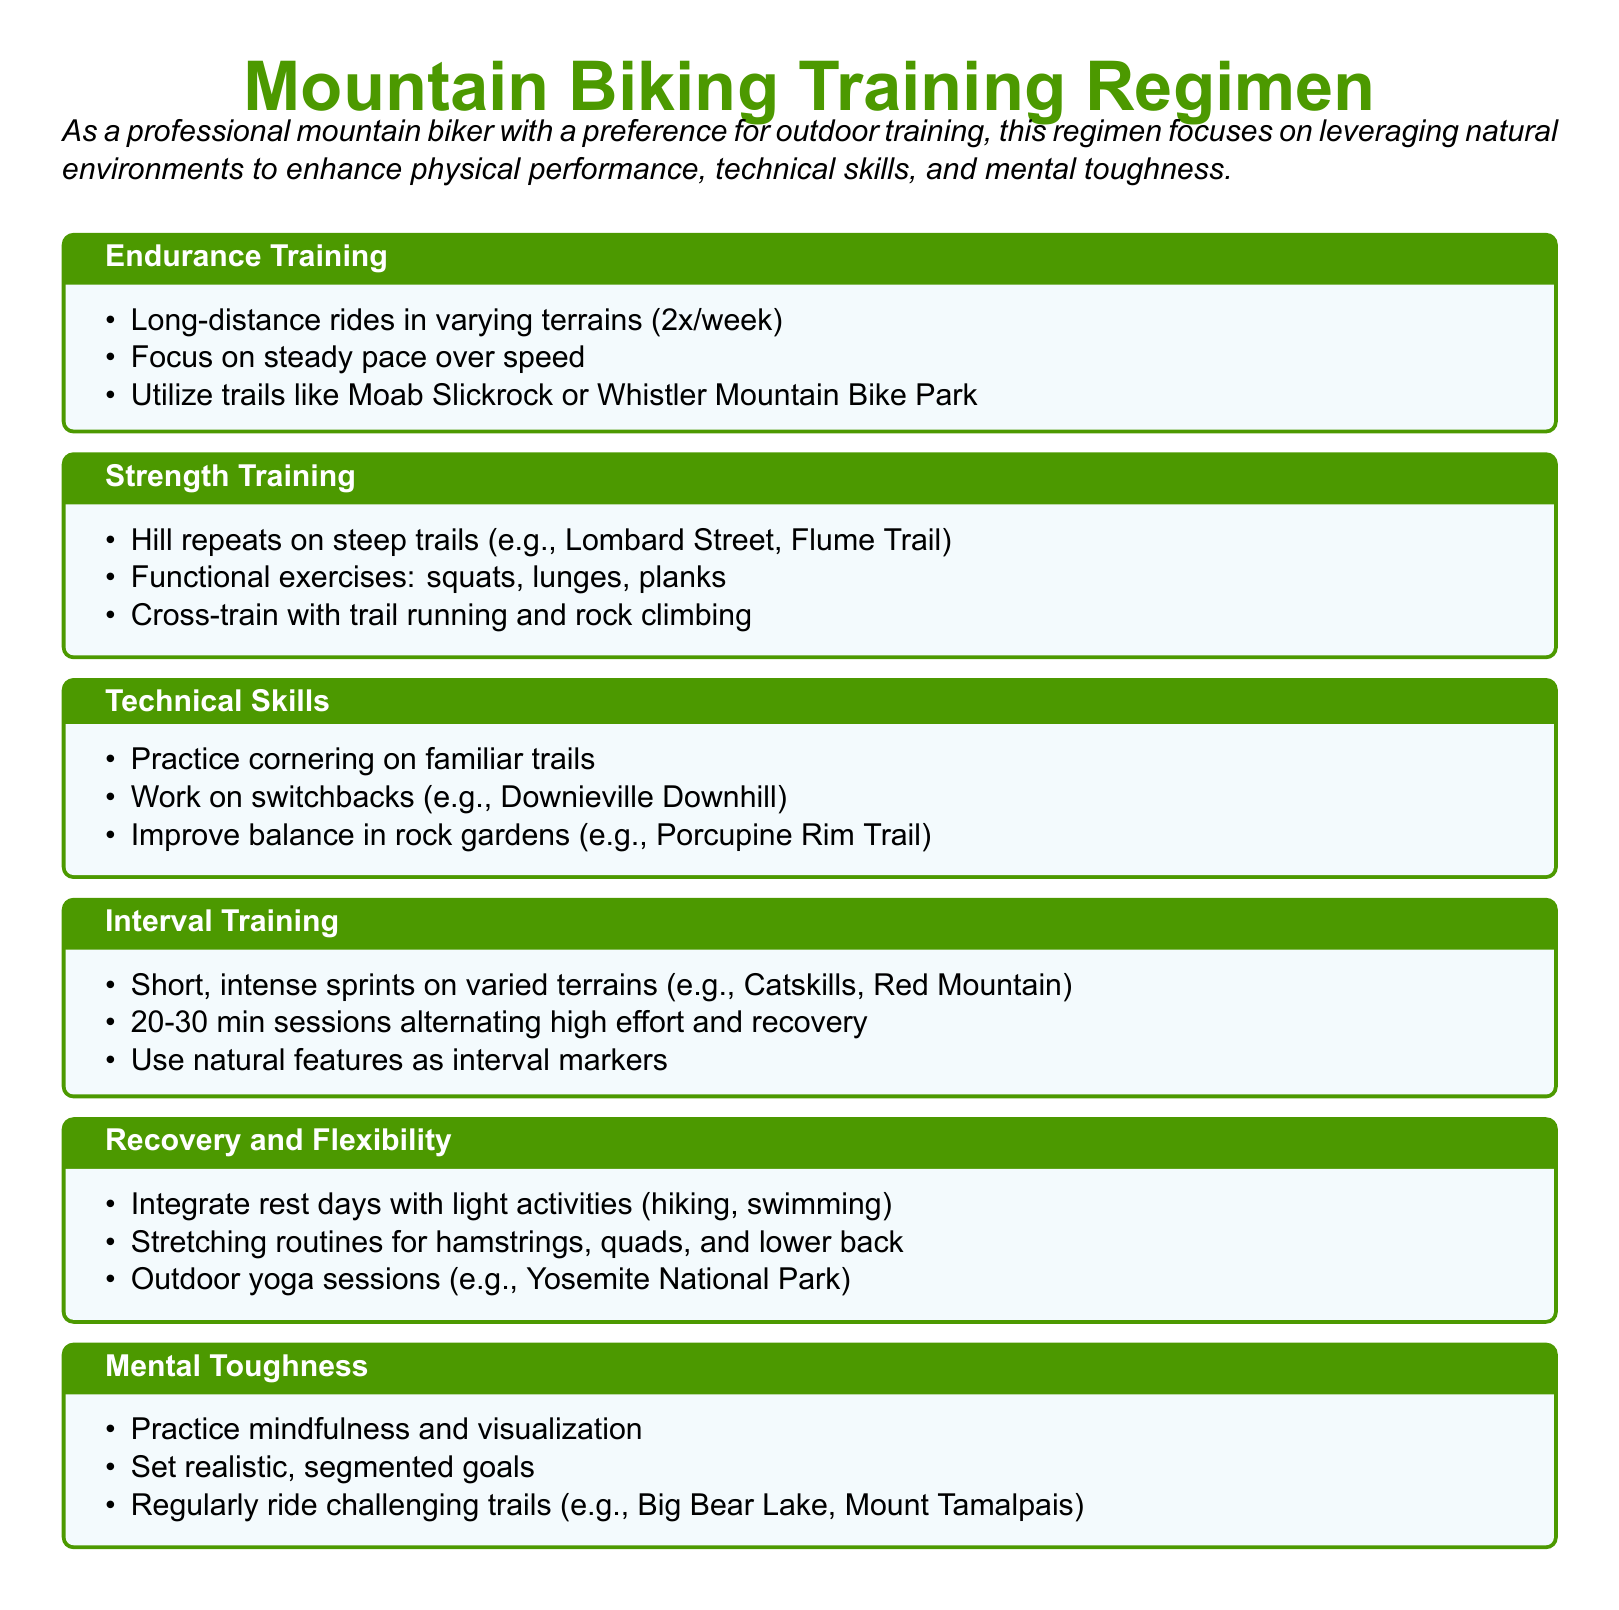What is the focus of the training regimen? The document states that the regimen focuses on leveraging natural environments to enhance physical performance, technical skills, and mental toughness.
Answer: leveraging natural environments How many days a week should endurance training occur? The document specifies that long-distance rides should take place twice a week.
Answer: 2x/week Name one location recommended for strength training hill repeats. The document mentions Lombard Street as a location for hill repeats in strength training.
Answer: Lombard Street What type of exercises are included in the strength training section? The document lists functional exercises such as squats, lunges, and planks under strength training.
Answer: squats, lunges, planks Which outdoor activity is suggested for recovery? The document mentions hiking as one of the light activities to integrate on rest days.
Answer: hiking What specific technique is recommended for improving balance? The document states that improving balance in rock gardens is a recommended technique.
Answer: rock gardens What is the duration of the interval training sessions? The document indicates that interval training sessions should last between 20 to 30 minutes.
Answer: 20-30 min Which park is suggested for outdoor yoga sessions? The document recommends Yosemite National Park for outdoor yoga sessions.
Answer: Yosemite National Park What skill is emphasized in the technical skills section? The document emphasizes the practice of cornering on familiar trails as a technical skill.
Answer: cornering 